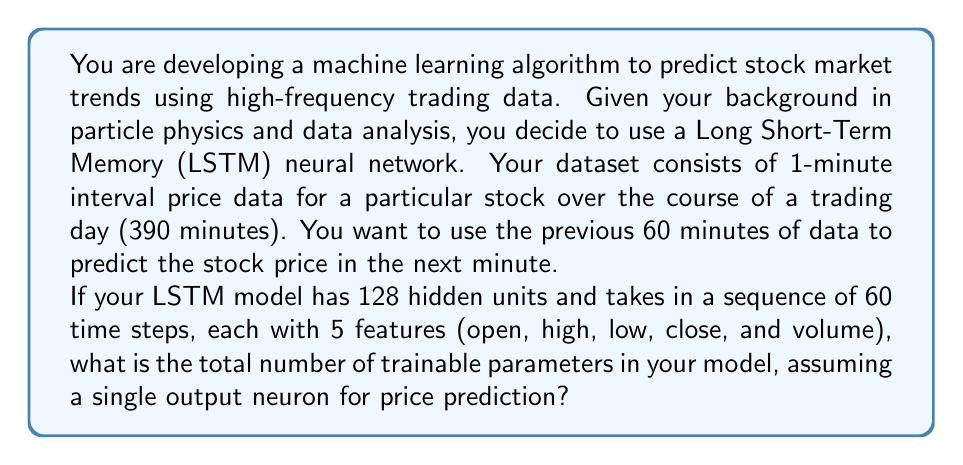Show me your answer to this math problem. To calculate the number of trainable parameters in an LSTM model, we need to consider the components of the LSTM cell and the output layer. Let's break it down step by step:

1. LSTM cell parameters:
   An LSTM cell has four gates (input, forget, output, and cell state), each requiring weights and biases.
   
   For each gate:
   - Weights for input: $5 \times 128 = 640$ (5 features, 128 hidden units)
   - Weights for recurrent connection: $128 \times 128 = 16,384$
   - Biases: $128$
   
   Total parameters per gate: $640 + 16,384 + 128 = 17,152$
   
   For all four gates: $17,152 \times 4 = 68,608$

2. Output layer parameters:
   - Weights: $128 \times 1 = 128$ (128 hidden units to 1 output neuron)
   - Bias: $1$
   
   Total output layer parameters: $128 + 1 = 129$

3. Total trainable parameters:
   LSTM cell parameters + Output layer parameters
   $68,608 + 129 = 68,737$

Therefore, the total number of trainable parameters in your LSTM model is 68,737.

This calculation is similar to determining the number of parameters in complex neural network architectures used in particle physics for event reconstruction or classification tasks.
Answer: 68,737 trainable parameters 